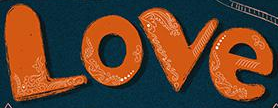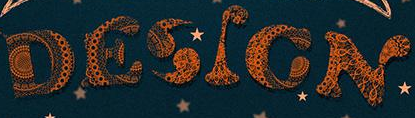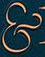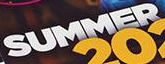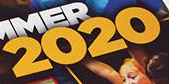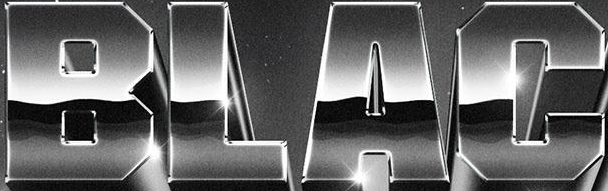What words can you see in these images in sequence, separated by a semicolon? Love; DESIGN; &; SUMMER; 2020; BLAC 